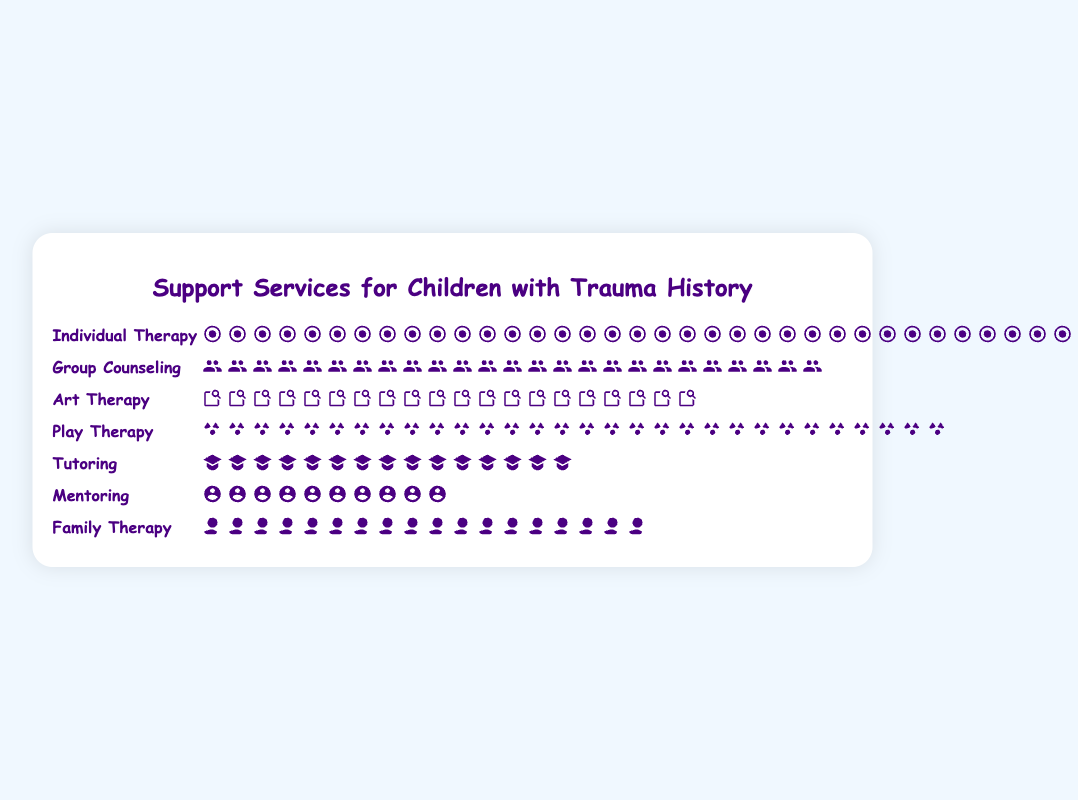What is the title of the figure? The title of the figure is large and centrally located at the top of the plot, making it clear and easy to see. The title reads "Support Services for Children with Trauma History".
Answer: Support Services for Children with Trauma History Which support service has the highest count? Each support service has icons representing its count. By scanning the rows, "Individual Therapy" has the most icons, indicating the highest count.
Answer: Individual Therapy How many services have a count higher than 20? By counting the rows of services with more than 20 icons, we see that "Individual Therapy" (35), "Group Counseling" (25), and "Play Therapy" (30) have counts above 20.
Answer: 3 What is the sum of the counts for "Tutoring" and "Mentoring"? To find the sum, add the counts for "Tutoring" (15) and "Mentoring" (10). This results in 15 + 10 = 25.
Answer: 25 Which service has a count closest to 20? "Art Therapy" has 20 icons, exactly matching the value. No other service has a count different from 20 that is closer to it.
Answer: Art Therapy How many icons are shown in total for all services? The sum of all counts can be calculated by adding: 35 (Individual Therapy) + 25 (Group Counseling) + 20 (Art Therapy) + 30 (Play Therapy) + 15 (Tutoring) + 10 (Mentoring) + 18 (Family Therapy) = 153.
Answer: 153 Compare "Play Therapy" and "Family Therapy". Which has more icons and by how much? "Play Therapy" has 30 icons, and "Family Therapy" has 18 icons. The difference is 30 - 18 = 12.
Answer: Play Therapy, by 12 Which service has the second lowest count, and what is the count? Scanning through the counts, "Mentoring" has the lowest with 10, and "Tutoring" is next with 15.
Answer: Tutoring, 15 What is the average count for all the support services? To find the average, sum all counts (153) and divide by the number of services (7), which results in 153 / 7 ≈ 21.86.
Answer: 21.86 